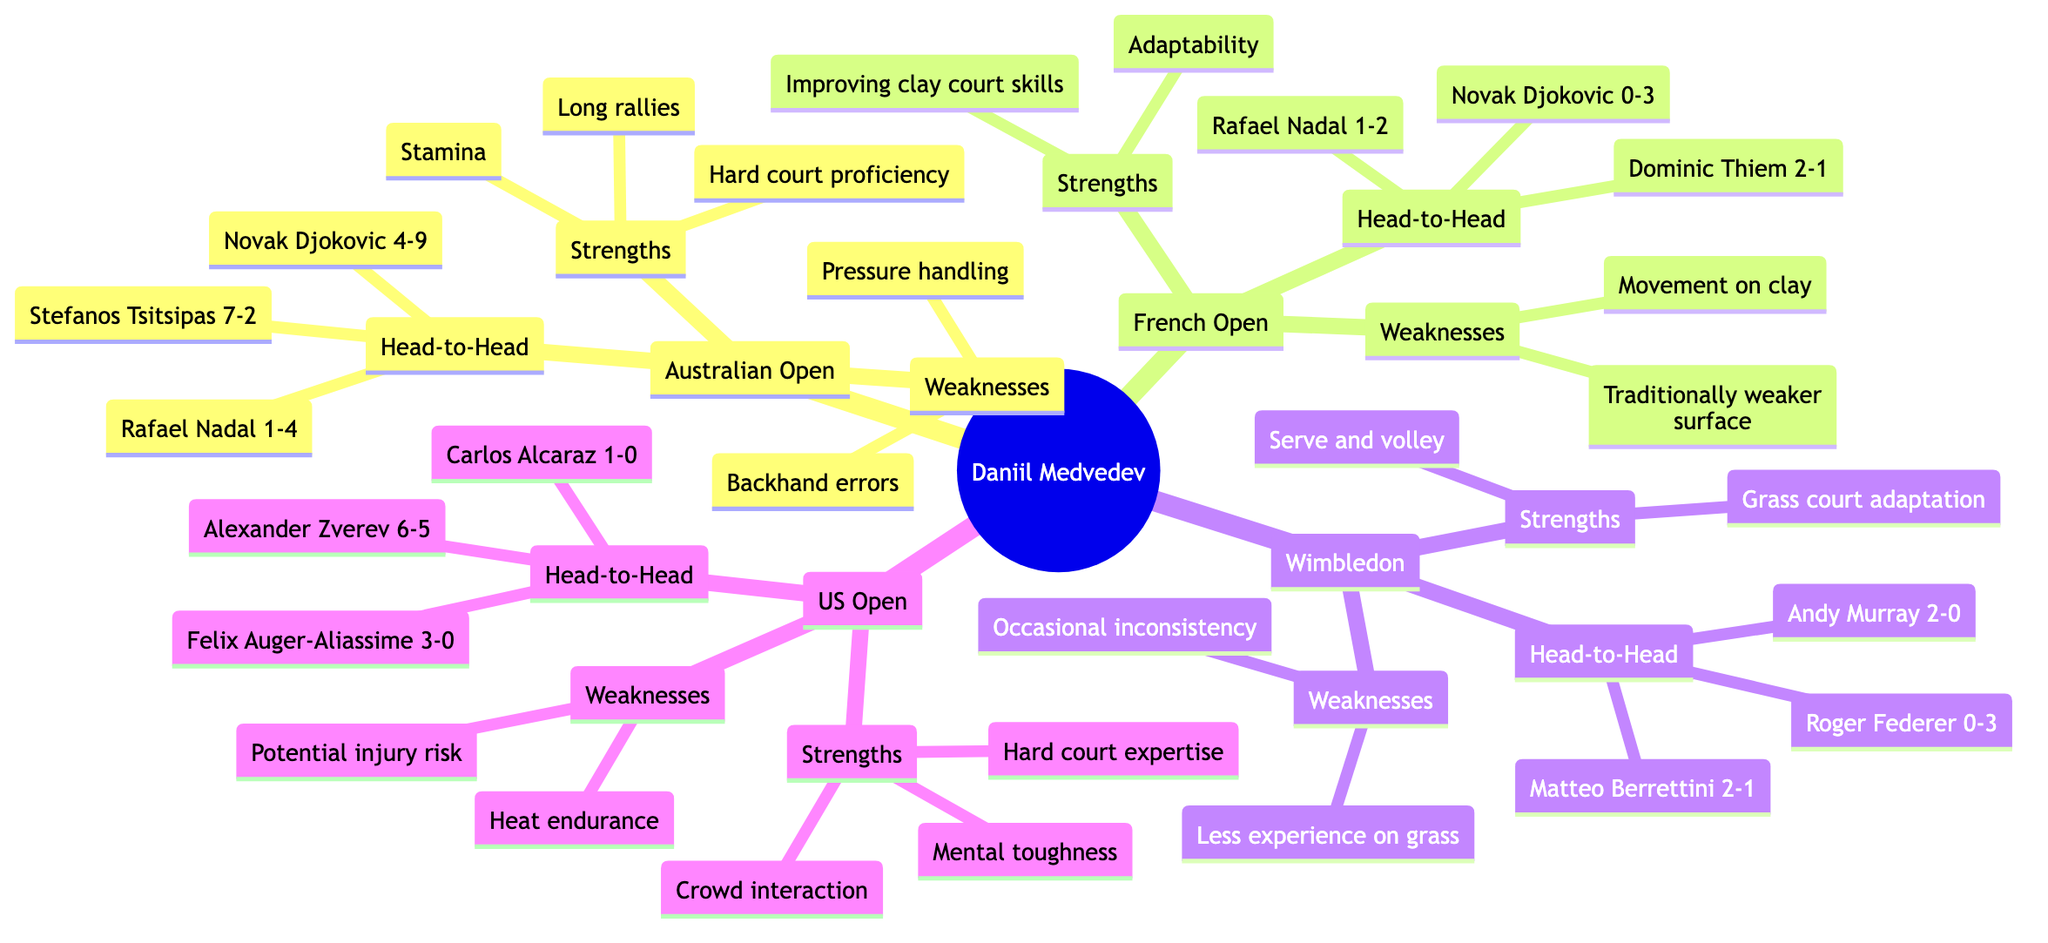What are Daniil Medvedev's strengths in the Australian Open? The diagram indicates that Medvedev's strengths in the Australian Open are "Hard court proficiency," "Long rallies," and "Stamina." These are explicitly listed under the Australian Open section, which directly answers the question.
Answer: Hard court proficiency, Long rallies, Stamina How many head-to-head wins does Medvedev have against Stefanos Tsitsipas in the Australian Open? By examining the Australian Open section of the diagram, it is noted that Medvedev has 7 wins against Tsitsipas and 2 losses, which gives him a total of 7 head-to-head wins in this specific competition.
Answer: 7 What is a major weakness for Medvedev on French Open clay courts? The Weaknesses section of the French Open in the diagram lists "Traditionally weaker surface" and "Movement on clay." This question asks for a specific weakness, and either of these answers would be correct, but "Traditionally weaker surface" is the more significant one associated with his performance.
Answer: Traditionally weaker surface Which Grand Slam has the strength of "Mental toughness" for Medvedev? The diagram shows that "Mental toughness" is listed under the Strengths for the US Open, confirming that this is the Grand Slam associated with this specific strength.
Answer: US Open How many matches has Medvedev won against Rafael Nadal in the French Open? The Head-to-Head stats indicate that against Rafael Nadal, Medvedev won 1 match and lost 2. Therefore, the answer to this question about the wins in this specific Grand Slam is straightforward based on the diagram's data.
Answer: 1 What are the weaknesses of Medvedev in Wimbledon? Referring to the Wimbledon section, the weaknesses mentioned are "Less experience on grass" and "Occasional inconsistency," both of which are outlined in the Weaknesses node for this Grand Slam event.
Answer: Less experience on grass, Occasional inconsistency Who has the superior head-to-head record against Medvedev in the Australian Open? Looking at the Head-to-Head statistics in the Australian Open section, Novak Djokovic has 4 wins to Medvedev's 9 losses, making him the player with a superior record against Medvedev.
Answer: Novak Djokovic Which Grand Slam features Medvedev's strength of "Crowd interaction"? The diagram indicates that "Crowd interaction" is listed under the US Open section, making this the correct answer for the Grand Slam that highlights this particular strength.
Answer: US Open 